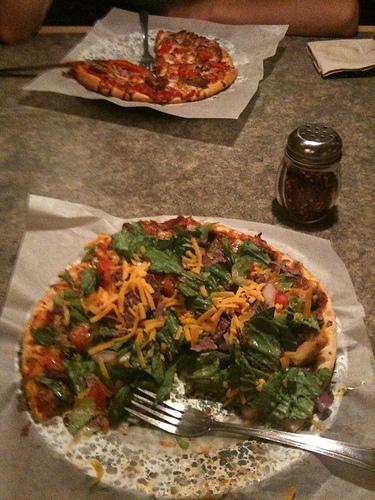What is in the picture?
Write a very short answer. Food. Are the tomatoes sliced or diced?
Answer briefly. Diced. Are any slices gone out of either pizza?
Short answer required. Yes. What kind of pizza is the closest one?
Be succinct. Veggie. What type of utensil is pictured?
Keep it brief. Fork. What spice is pictured?
Quick response, please. Pepper. Is the pizza whole?
Be succinct. No. 